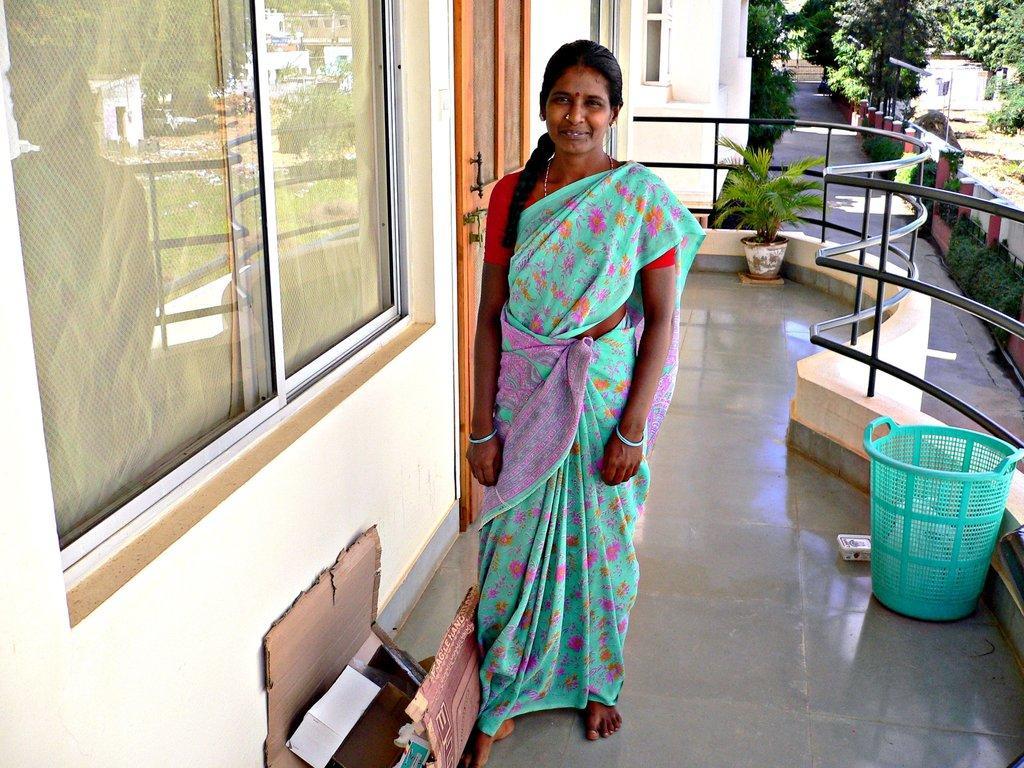Describe this image in one or two sentences. In this image, we can see a few houses. We can see a lady standing. We can see the ground with some objects like a flower pot, a basket and some cardboards. We can also see the window and a door. We can see some plants, trees. We can also see some poles. 